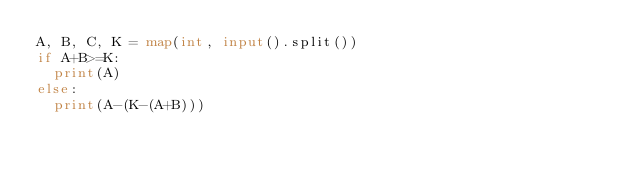<code> <loc_0><loc_0><loc_500><loc_500><_Python_>A, B, C, K = map(int, input().split())
if A+B>=K:
  print(A)
else:
  print(A-(K-(A+B)))
</code> 